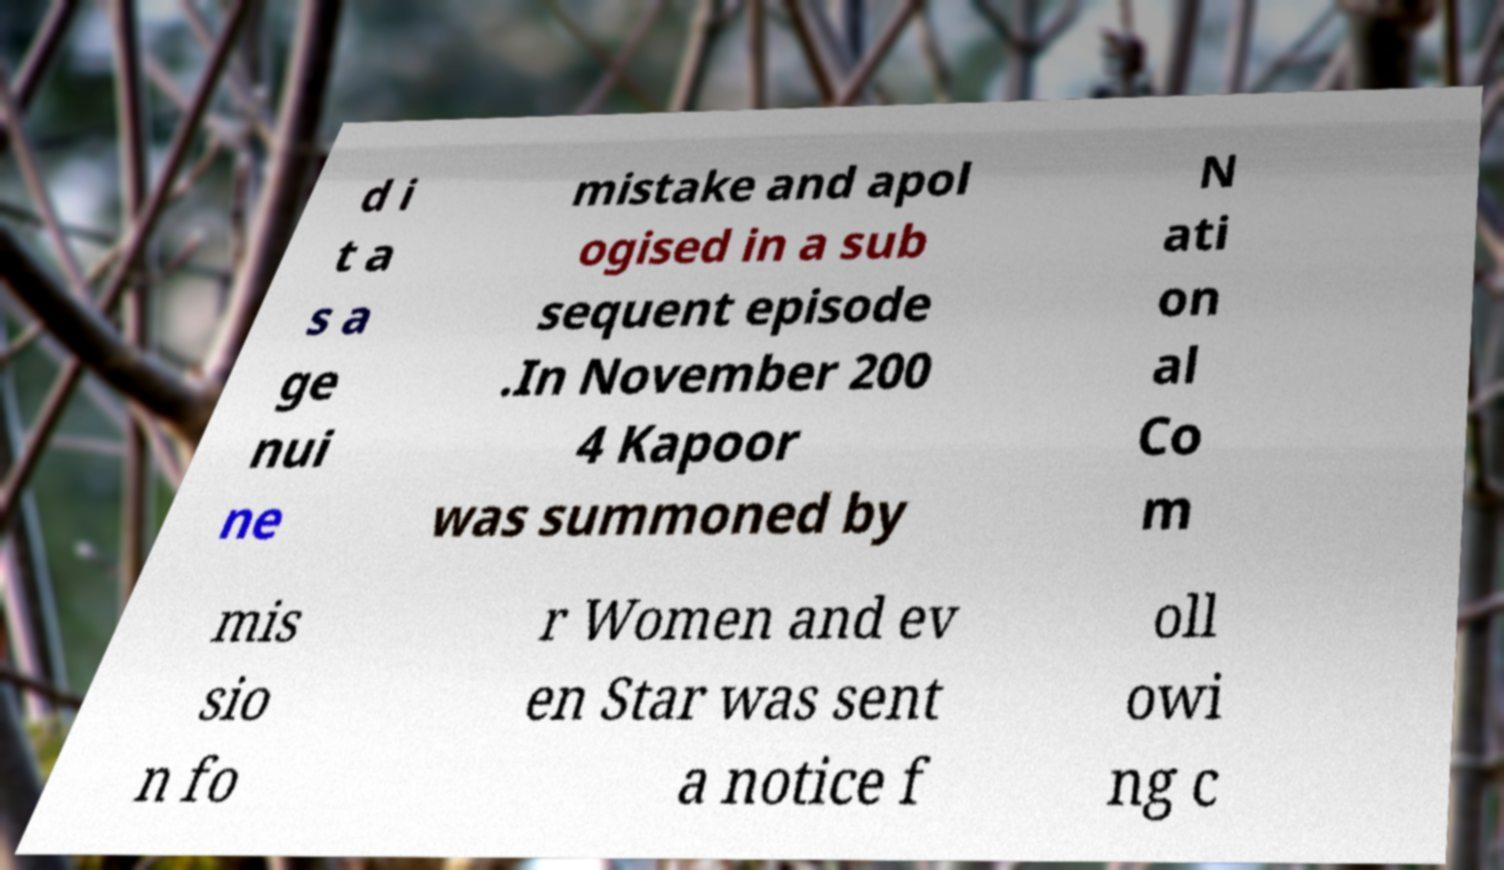I need the written content from this picture converted into text. Can you do that? d i t a s a ge nui ne mistake and apol ogised in a sub sequent episode .In November 200 4 Kapoor was summoned by N ati on al Co m mis sio n fo r Women and ev en Star was sent a notice f oll owi ng c 